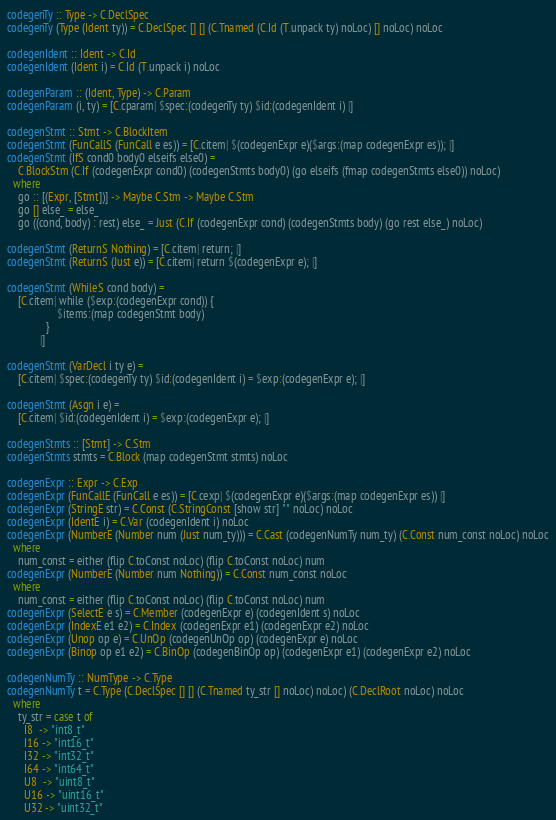<code> <loc_0><loc_0><loc_500><loc_500><_Haskell_>codegenTy :: Type -> C.DeclSpec
codegenTy (Type (Ident ty)) = C.DeclSpec [] [] (C.Tnamed (C.Id (T.unpack ty) noLoc) [] noLoc) noLoc

codegenIdent :: Ident -> C.Id
codegenIdent (Ident i) = C.Id (T.unpack i) noLoc

codegenParam :: (Ident, Type) -> C.Param
codegenParam (i, ty) = [C.cparam| $spec:(codegenTy ty) $id:(codegenIdent i) |]

codegenStmt :: Stmt -> C.BlockItem
codegenStmt (FunCallS (FunCall e es)) = [C.citem| $(codegenExpr e)($args:(map codegenExpr es)); |]
codegenStmt (IfS cond0 body0 elseifs else0) =
    C.BlockStm (C.If (codegenExpr cond0) (codegenStmts body0) (go elseifs (fmap codegenStmts else0)) noLoc)
  where
    go :: [(Expr, [Stmt])] -> Maybe C.Stm -> Maybe C.Stm
    go [] else_ = else_
    go ((cond, body) : rest) else_ = Just (C.If (codegenExpr cond) (codegenStmts body) (go rest else_) noLoc)

codegenStmt (ReturnS Nothing) = [C.citem| return; |]
codegenStmt (ReturnS (Just e)) = [C.citem| return $(codegenExpr e); |]

codegenStmt (WhileS cond body) =
    [C.citem| while ($exp:(codegenExpr cond)) {
                  $items:(map codegenStmt body)
              }
            |]

codegenStmt (VarDecl i ty e) =
    [C.citem| $spec:(codegenTy ty) $id:(codegenIdent i) = $exp:(codegenExpr e); |]

codegenStmt (Asgn i e) =
    [C.citem| $id:(codegenIdent i) = $exp:(codegenExpr e); |]

codegenStmts :: [Stmt] -> C.Stm
codegenStmts stmts = C.Block (map codegenStmt stmts) noLoc

codegenExpr :: Expr -> C.Exp
codegenExpr (FunCallE (FunCall e es)) = [C.cexp| $(codegenExpr e)($args:(map codegenExpr es)) |]
codegenExpr (StringE str) = C.Const (C.StringConst [show str] "" noLoc) noLoc
codegenExpr (IdentE i) = C.Var (codegenIdent i) noLoc
codegenExpr (NumberE (Number num (Just num_ty))) = C.Cast (codegenNumTy num_ty) (C.Const num_const noLoc) noLoc
  where
    num_const = either (flip C.toConst noLoc) (flip C.toConst noLoc) num
codegenExpr (NumberE (Number num Nothing)) = C.Const num_const noLoc
  where
    num_const = either (flip C.toConst noLoc) (flip C.toConst noLoc) num
codegenExpr (SelectE e s) = C.Member (codegenExpr e) (codegenIdent s) noLoc
codegenExpr (IndexE e1 e2) = C.Index (codegenExpr e1) (codegenExpr e2) noLoc
codegenExpr (Unop op e) = C.UnOp (codegenUnOp op) (codegenExpr e) noLoc
codegenExpr (Binop op e1 e2) = C.BinOp (codegenBinOp op) (codegenExpr e1) (codegenExpr e2) noLoc

codegenNumTy :: NumType -> C.Type
codegenNumTy t = C.Type (C.DeclSpec [] [] (C.Tnamed ty_str [] noLoc) noLoc) (C.DeclRoot noLoc) noLoc
  where
    ty_str = case t of
      I8  -> "int8_t"
      I16 -> "int16_t"
      I32 -> "int32_t"
      I64 -> "int64_t"
      U8  -> "uint8_t"
      U16 -> "uint16_t"
      U32 -> "uint32_t"</code> 